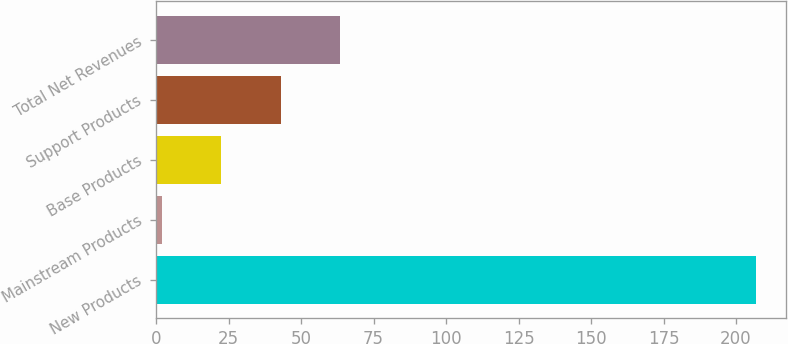Convert chart. <chart><loc_0><loc_0><loc_500><loc_500><bar_chart><fcel>New Products<fcel>Mainstream Products<fcel>Base Products<fcel>Support Products<fcel>Total Net Revenues<nl><fcel>207<fcel>1.96<fcel>22.46<fcel>42.96<fcel>63.46<nl></chart> 